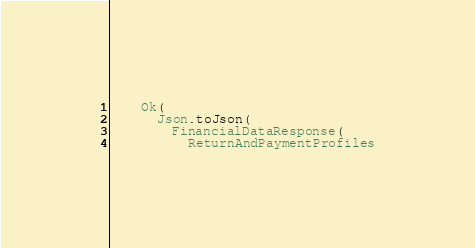<code> <loc_0><loc_0><loc_500><loc_500><_Scala_>    Ok(
      Json.toJson(
        FinancialDataResponse(
          ReturnAndPaymentProfiles</code> 